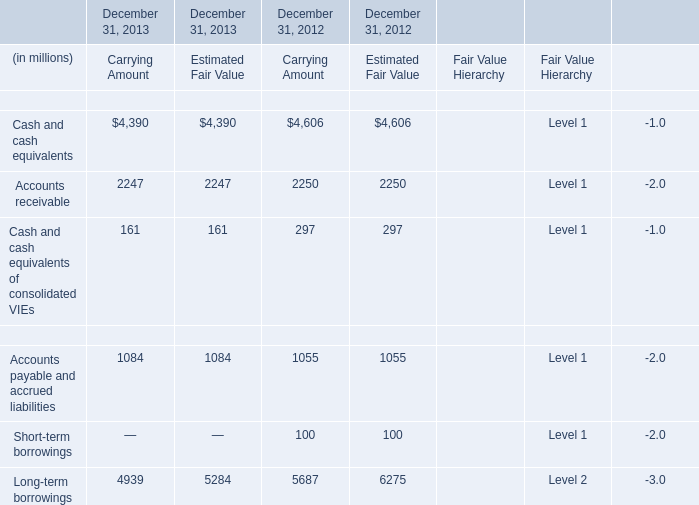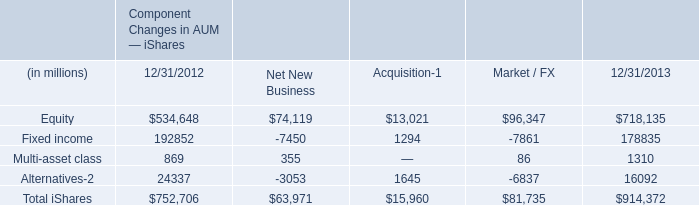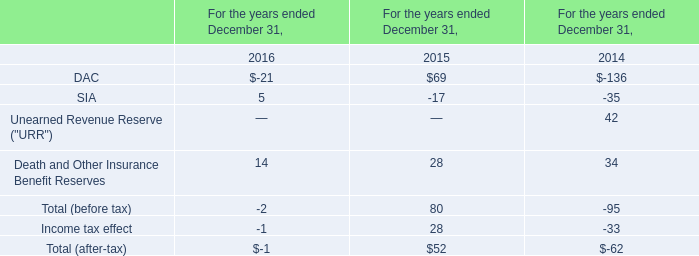In what year is Cash and cash equivalents of consolidated VIEs in carrying amount greater than 200? 
Answer: 297. 